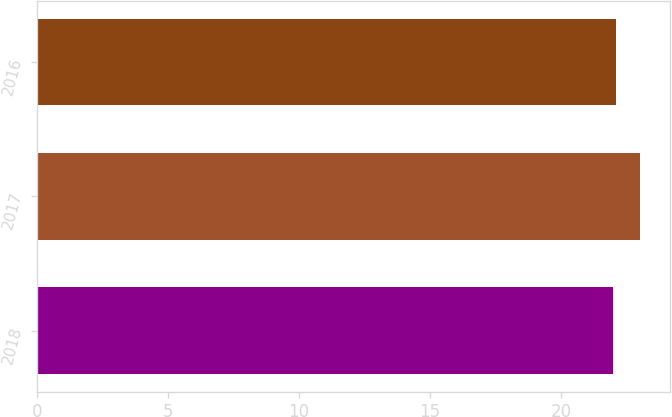<chart> <loc_0><loc_0><loc_500><loc_500><bar_chart><fcel>2018<fcel>2017<fcel>2016<nl><fcel>22<fcel>23<fcel>22.1<nl></chart> 